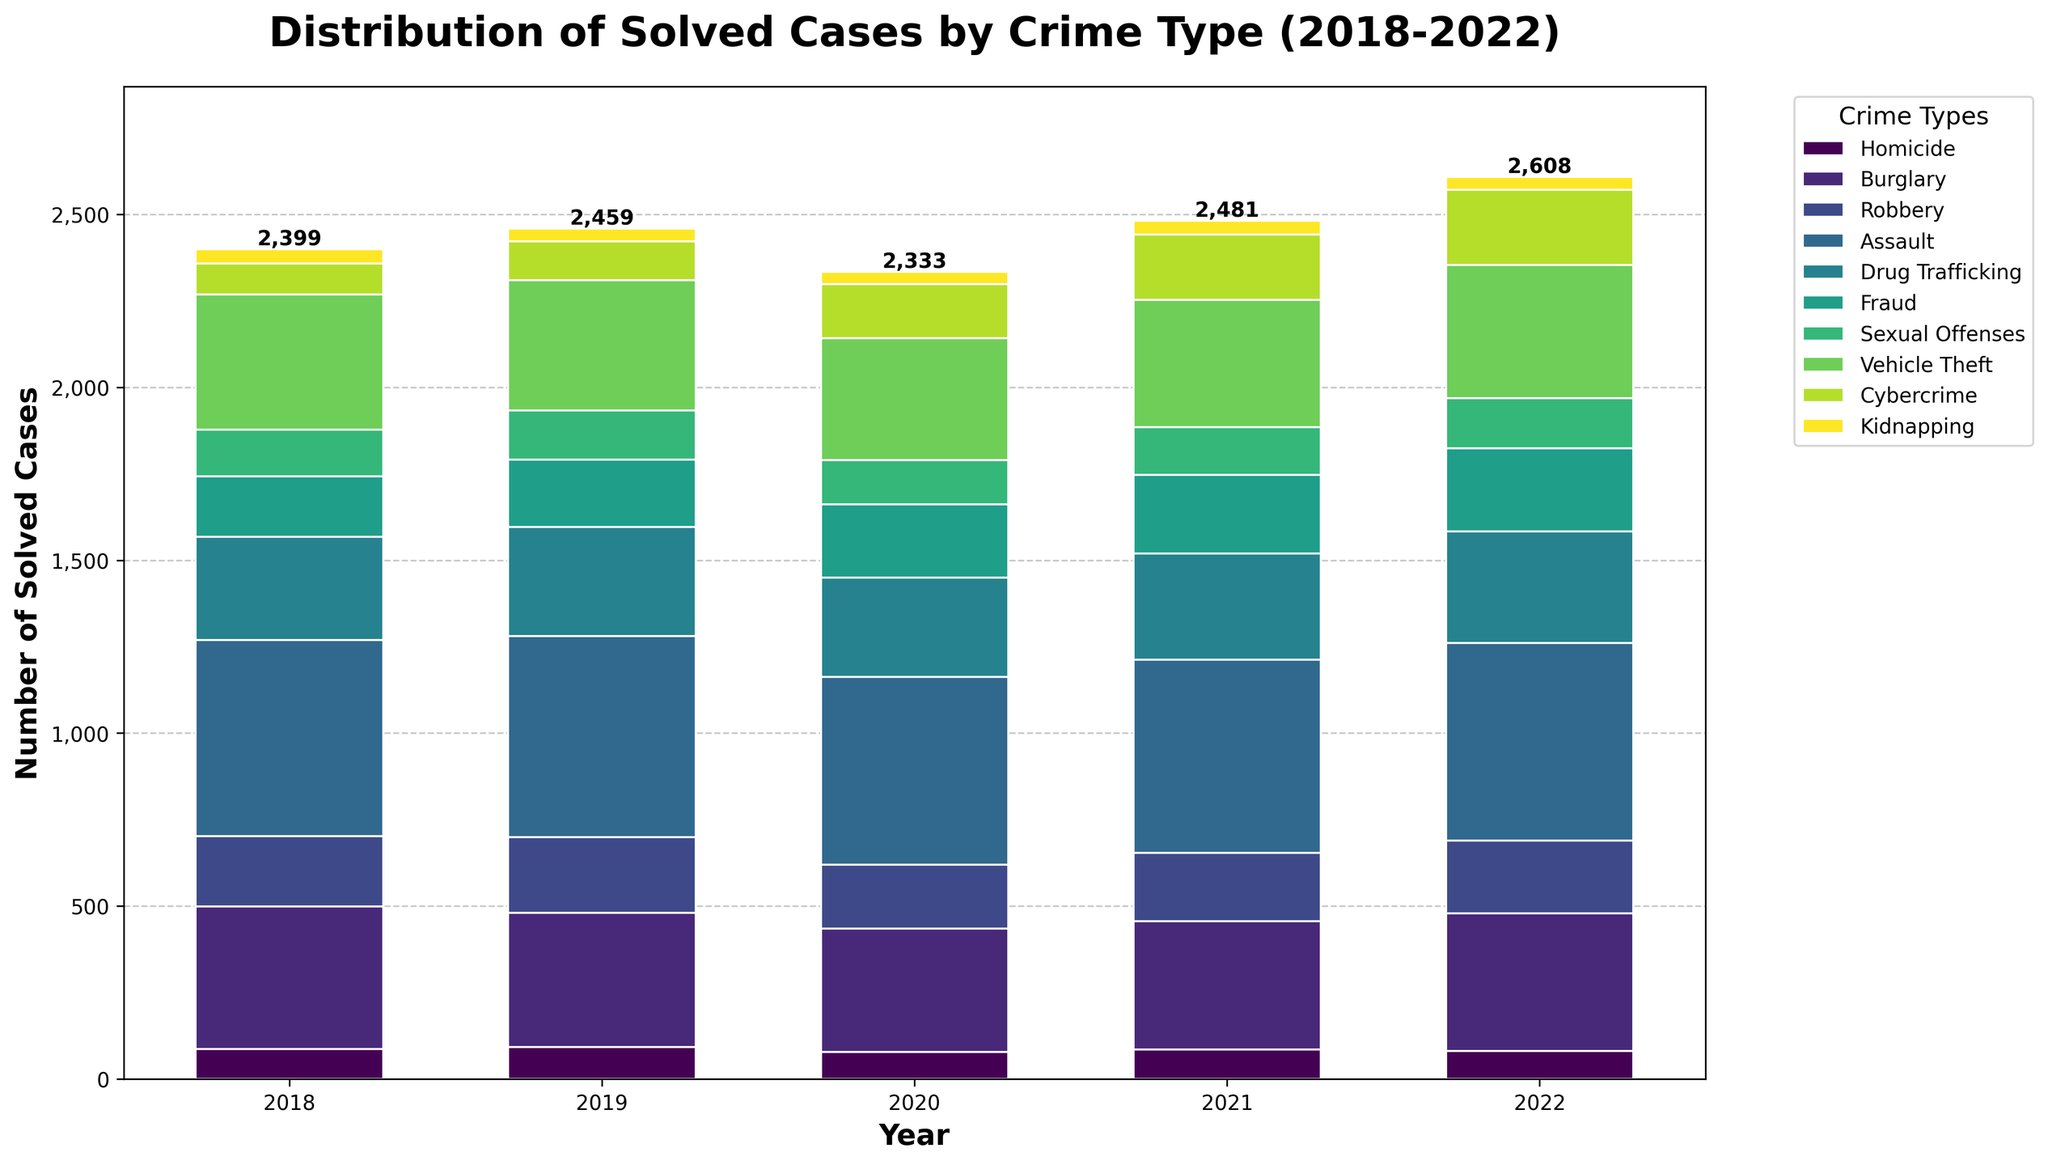What's the total number of solved cases for the year 2020? To find the total number of solved cases in 2020, add the numbers from each crime type for that year: 79 (Homicide) + 356 (Burglary) + 185 (Robbery) + 543 (Assault) + 287 (Drug Trafficking) + 212 (Fraud) + 128 (Sexual Offenses) + 352 (Vehicle Theft) + 156 (Cybercrime) + 35 (Kidnapping). This equals 2333.
Answer: 2333 Which year had the highest number of solved cybercrime cases? To determine the year with the highest number of solved cybercrime cases, compare the values for Cybercrime across the years: 2018 (89), 2019 (112), 2020 (156), 2021 (189), and 2022 (217). Year 2022 has the highest number (217).
Answer: 2022 In which year did the number of solved burglary cases drop the most compared to the previous year? Calculate the difference in solved burglary cases for each year compared to the previous one: 2019-2018 = 389-412 = -23, 2020-2019 = 356-389 = -33, 2021-2020 = 372-356 = 16, 2022-2021 = 398-372 = 26. The biggest drop is between 2019 and 2020, with a decrease of 33 cases.
Answer: 2020 What is the average number of solved assault cases over the 5-year period? To find the average, sum the number of solved assault cases for each year and divide by 5: (567 + 582 + 543 + 559 + 571) / 5 = 2822 / 5 = 564.4.
Answer: 564.4 Which crime type had the smallest number of solved cases consistently each year? By comparing each crime type over the years, Kidnapping has the lowest values consistently: 2018 (42), 2019 (38), 2020 (35), 2021 (40), 2022 (37).
Answer: Kidnapping What's the difference in the number of solved drug trafficking cases between 2018 and 2022? Subtract the number of solved drug trafficking cases in 2018 from that of 2022: 2022 (322) - 2018 (298) = 24.
Answer: 24 How many solved fraud cases were there in 2019, and how does it compare to Vehicle Theft in the same year? Find the number of solved fraud cases in 2019 and compare it to vehicle theft: Fraud (195) vs. Vehicle Theft (376). Fraud has fewer solved cases (195).
Answer: 195, fewer than Vehicle Theft Which crime type showed the most growth in solved cases from 2018 to 2022? Subtract the 2018 values from the 2022 values for each crime type and find which has the largest growth: Cybercrime increased by the most (217 - 89 = 128).
Answer: Cybercrime What is the total number of solved homicide cases over the period? Sum the number of solved homicide cases from 2018 to 2022: 87 + 92 + 79 + 85 + 81 = 424.
Answer: 424 